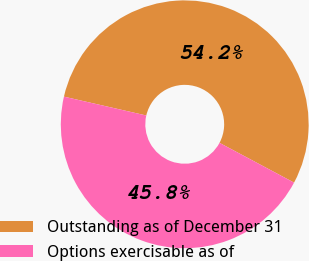<chart> <loc_0><loc_0><loc_500><loc_500><pie_chart><fcel>Outstanding as of December 31<fcel>Options exercisable as of<nl><fcel>54.22%<fcel>45.78%<nl></chart> 